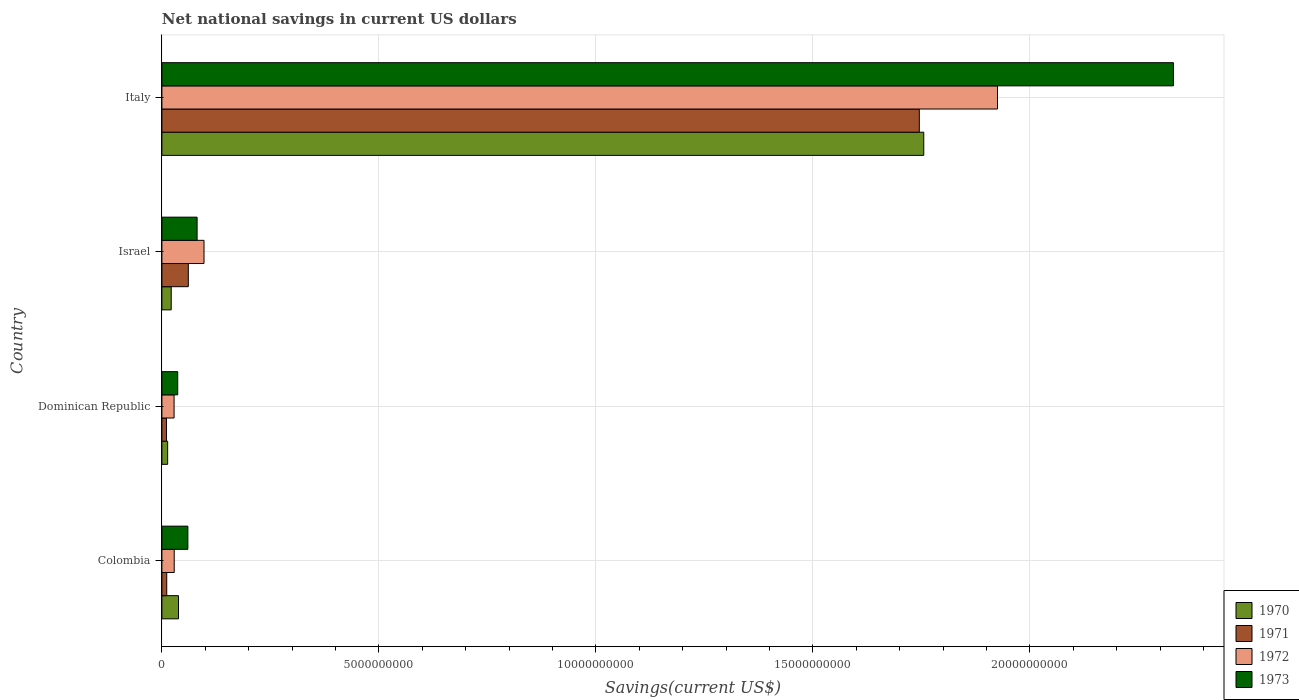Are the number of bars per tick equal to the number of legend labels?
Offer a terse response. Yes. Are the number of bars on each tick of the Y-axis equal?
Give a very brief answer. Yes. How many bars are there on the 4th tick from the top?
Make the answer very short. 4. How many bars are there on the 3rd tick from the bottom?
Provide a succinct answer. 4. What is the label of the 4th group of bars from the top?
Keep it short and to the point. Colombia. In how many cases, is the number of bars for a given country not equal to the number of legend labels?
Ensure brevity in your answer.  0. What is the net national savings in 1973 in Israel?
Offer a terse response. 8.11e+08. Across all countries, what is the maximum net national savings in 1970?
Your answer should be very brief. 1.76e+1. Across all countries, what is the minimum net national savings in 1973?
Make the answer very short. 3.65e+08. In which country was the net national savings in 1972 maximum?
Ensure brevity in your answer.  Italy. In which country was the net national savings in 1971 minimum?
Ensure brevity in your answer.  Dominican Republic. What is the total net national savings in 1972 in the graph?
Your response must be concise. 2.08e+1. What is the difference between the net national savings in 1971 in Dominican Republic and that in Israel?
Provide a succinct answer. -5.03e+08. What is the difference between the net national savings in 1973 in Dominican Republic and the net national savings in 1971 in Italy?
Offer a terse response. -1.71e+1. What is the average net national savings in 1972 per country?
Your response must be concise. 5.20e+09. What is the difference between the net national savings in 1972 and net national savings in 1973 in Colombia?
Provide a short and direct response. -3.14e+08. What is the ratio of the net national savings in 1973 in Dominican Republic to that in Israel?
Your response must be concise. 0.45. Is the difference between the net national savings in 1972 in Israel and Italy greater than the difference between the net national savings in 1973 in Israel and Italy?
Your answer should be very brief. Yes. What is the difference between the highest and the second highest net national savings in 1972?
Offer a very short reply. 1.83e+1. What is the difference between the highest and the lowest net national savings in 1972?
Provide a short and direct response. 1.90e+1. In how many countries, is the net national savings in 1971 greater than the average net national savings in 1971 taken over all countries?
Offer a very short reply. 1. Is the sum of the net national savings in 1972 in Israel and Italy greater than the maximum net national savings in 1971 across all countries?
Ensure brevity in your answer.  Yes. Is it the case that in every country, the sum of the net national savings in 1970 and net national savings in 1971 is greater than the sum of net national savings in 1972 and net national savings in 1973?
Provide a short and direct response. No. What does the 2nd bar from the top in Dominican Republic represents?
Your response must be concise. 1972. Is it the case that in every country, the sum of the net national savings in 1971 and net national savings in 1972 is greater than the net national savings in 1973?
Provide a short and direct response. No. How many bars are there?
Keep it short and to the point. 16. How many countries are there in the graph?
Ensure brevity in your answer.  4. What is the difference between two consecutive major ticks on the X-axis?
Offer a very short reply. 5.00e+09. Does the graph contain any zero values?
Ensure brevity in your answer.  No. How are the legend labels stacked?
Your response must be concise. Vertical. What is the title of the graph?
Give a very brief answer. Net national savings in current US dollars. Does "1961" appear as one of the legend labels in the graph?
Make the answer very short. No. What is the label or title of the X-axis?
Offer a terse response. Savings(current US$). What is the label or title of the Y-axis?
Ensure brevity in your answer.  Country. What is the Savings(current US$) in 1970 in Colombia?
Your answer should be compact. 3.83e+08. What is the Savings(current US$) in 1971 in Colombia?
Keep it short and to the point. 1.11e+08. What is the Savings(current US$) in 1972 in Colombia?
Ensure brevity in your answer.  2.84e+08. What is the Savings(current US$) of 1973 in Colombia?
Your answer should be compact. 5.98e+08. What is the Savings(current US$) in 1970 in Dominican Republic?
Your response must be concise. 1.33e+08. What is the Savings(current US$) in 1971 in Dominican Republic?
Make the answer very short. 1.05e+08. What is the Savings(current US$) of 1972 in Dominican Republic?
Your answer should be very brief. 2.80e+08. What is the Savings(current US$) of 1973 in Dominican Republic?
Provide a succinct answer. 3.65e+08. What is the Savings(current US$) in 1970 in Israel?
Ensure brevity in your answer.  2.15e+08. What is the Savings(current US$) in 1971 in Israel?
Your answer should be compact. 6.09e+08. What is the Savings(current US$) in 1972 in Israel?
Make the answer very short. 9.71e+08. What is the Savings(current US$) of 1973 in Israel?
Offer a terse response. 8.11e+08. What is the Savings(current US$) in 1970 in Italy?
Ensure brevity in your answer.  1.76e+1. What is the Savings(current US$) of 1971 in Italy?
Keep it short and to the point. 1.75e+1. What is the Savings(current US$) of 1972 in Italy?
Offer a very short reply. 1.93e+1. What is the Savings(current US$) of 1973 in Italy?
Offer a terse response. 2.33e+1. Across all countries, what is the maximum Savings(current US$) in 1970?
Provide a succinct answer. 1.76e+1. Across all countries, what is the maximum Savings(current US$) in 1971?
Offer a very short reply. 1.75e+1. Across all countries, what is the maximum Savings(current US$) in 1972?
Provide a short and direct response. 1.93e+1. Across all countries, what is the maximum Savings(current US$) of 1973?
Your answer should be compact. 2.33e+1. Across all countries, what is the minimum Savings(current US$) in 1970?
Keep it short and to the point. 1.33e+08. Across all countries, what is the minimum Savings(current US$) in 1971?
Give a very brief answer. 1.05e+08. Across all countries, what is the minimum Savings(current US$) of 1972?
Your answer should be compact. 2.80e+08. Across all countries, what is the minimum Savings(current US$) in 1973?
Make the answer very short. 3.65e+08. What is the total Savings(current US$) in 1970 in the graph?
Offer a very short reply. 1.83e+1. What is the total Savings(current US$) of 1971 in the graph?
Your response must be concise. 1.83e+1. What is the total Savings(current US$) of 1972 in the graph?
Provide a short and direct response. 2.08e+1. What is the total Savings(current US$) of 1973 in the graph?
Provide a succinct answer. 2.51e+1. What is the difference between the Savings(current US$) of 1970 in Colombia and that in Dominican Republic?
Your answer should be very brief. 2.50e+08. What is the difference between the Savings(current US$) in 1971 in Colombia and that in Dominican Republic?
Provide a succinct answer. 6.03e+06. What is the difference between the Savings(current US$) in 1972 in Colombia and that in Dominican Republic?
Offer a very short reply. 3.48e+06. What is the difference between the Savings(current US$) of 1973 in Colombia and that in Dominican Republic?
Keep it short and to the point. 2.34e+08. What is the difference between the Savings(current US$) of 1970 in Colombia and that in Israel?
Your answer should be very brief. 1.68e+08. What is the difference between the Savings(current US$) in 1971 in Colombia and that in Israel?
Your response must be concise. -4.97e+08. What is the difference between the Savings(current US$) of 1972 in Colombia and that in Israel?
Provide a succinct answer. -6.87e+08. What is the difference between the Savings(current US$) of 1973 in Colombia and that in Israel?
Your answer should be compact. -2.12e+08. What is the difference between the Savings(current US$) in 1970 in Colombia and that in Italy?
Your response must be concise. -1.72e+1. What is the difference between the Savings(current US$) in 1971 in Colombia and that in Italy?
Your answer should be compact. -1.73e+1. What is the difference between the Savings(current US$) in 1972 in Colombia and that in Italy?
Give a very brief answer. -1.90e+1. What is the difference between the Savings(current US$) in 1973 in Colombia and that in Italy?
Make the answer very short. -2.27e+1. What is the difference between the Savings(current US$) of 1970 in Dominican Republic and that in Israel?
Provide a succinct answer. -8.19e+07. What is the difference between the Savings(current US$) in 1971 in Dominican Republic and that in Israel?
Give a very brief answer. -5.03e+08. What is the difference between the Savings(current US$) of 1972 in Dominican Republic and that in Israel?
Your answer should be very brief. -6.90e+08. What is the difference between the Savings(current US$) of 1973 in Dominican Republic and that in Israel?
Your answer should be very brief. -4.46e+08. What is the difference between the Savings(current US$) of 1970 in Dominican Republic and that in Italy?
Offer a very short reply. -1.74e+1. What is the difference between the Savings(current US$) of 1971 in Dominican Republic and that in Italy?
Make the answer very short. -1.73e+1. What is the difference between the Savings(current US$) of 1972 in Dominican Republic and that in Italy?
Your response must be concise. -1.90e+1. What is the difference between the Savings(current US$) in 1973 in Dominican Republic and that in Italy?
Offer a terse response. -2.29e+1. What is the difference between the Savings(current US$) in 1970 in Israel and that in Italy?
Ensure brevity in your answer.  -1.73e+1. What is the difference between the Savings(current US$) in 1971 in Israel and that in Italy?
Your answer should be very brief. -1.68e+1. What is the difference between the Savings(current US$) of 1972 in Israel and that in Italy?
Keep it short and to the point. -1.83e+1. What is the difference between the Savings(current US$) in 1973 in Israel and that in Italy?
Your answer should be compact. -2.25e+1. What is the difference between the Savings(current US$) of 1970 in Colombia and the Savings(current US$) of 1971 in Dominican Republic?
Your response must be concise. 2.77e+08. What is the difference between the Savings(current US$) of 1970 in Colombia and the Savings(current US$) of 1972 in Dominican Republic?
Give a very brief answer. 1.02e+08. What is the difference between the Savings(current US$) of 1970 in Colombia and the Savings(current US$) of 1973 in Dominican Republic?
Provide a short and direct response. 1.82e+07. What is the difference between the Savings(current US$) of 1971 in Colombia and the Savings(current US$) of 1972 in Dominican Republic?
Provide a short and direct response. -1.69e+08. What is the difference between the Savings(current US$) in 1971 in Colombia and the Savings(current US$) in 1973 in Dominican Republic?
Provide a succinct answer. -2.53e+08. What is the difference between the Savings(current US$) in 1972 in Colombia and the Savings(current US$) in 1973 in Dominican Republic?
Give a very brief answer. -8.05e+07. What is the difference between the Savings(current US$) of 1970 in Colombia and the Savings(current US$) of 1971 in Israel?
Offer a terse response. -2.26e+08. What is the difference between the Savings(current US$) of 1970 in Colombia and the Savings(current US$) of 1972 in Israel?
Provide a succinct answer. -5.88e+08. What is the difference between the Savings(current US$) of 1970 in Colombia and the Savings(current US$) of 1973 in Israel?
Make the answer very short. -4.28e+08. What is the difference between the Savings(current US$) of 1971 in Colombia and the Savings(current US$) of 1972 in Israel?
Your response must be concise. -8.59e+08. What is the difference between the Savings(current US$) of 1971 in Colombia and the Savings(current US$) of 1973 in Israel?
Provide a short and direct response. -6.99e+08. What is the difference between the Savings(current US$) in 1972 in Colombia and the Savings(current US$) in 1973 in Israel?
Give a very brief answer. -5.27e+08. What is the difference between the Savings(current US$) in 1970 in Colombia and the Savings(current US$) in 1971 in Italy?
Give a very brief answer. -1.71e+1. What is the difference between the Savings(current US$) in 1970 in Colombia and the Savings(current US$) in 1972 in Italy?
Ensure brevity in your answer.  -1.89e+1. What is the difference between the Savings(current US$) of 1970 in Colombia and the Savings(current US$) of 1973 in Italy?
Ensure brevity in your answer.  -2.29e+1. What is the difference between the Savings(current US$) of 1971 in Colombia and the Savings(current US$) of 1972 in Italy?
Provide a succinct answer. -1.91e+1. What is the difference between the Savings(current US$) of 1971 in Colombia and the Savings(current US$) of 1973 in Italy?
Your answer should be compact. -2.32e+1. What is the difference between the Savings(current US$) in 1972 in Colombia and the Savings(current US$) in 1973 in Italy?
Give a very brief answer. -2.30e+1. What is the difference between the Savings(current US$) in 1970 in Dominican Republic and the Savings(current US$) in 1971 in Israel?
Give a very brief answer. -4.76e+08. What is the difference between the Savings(current US$) of 1970 in Dominican Republic and the Savings(current US$) of 1972 in Israel?
Ensure brevity in your answer.  -8.38e+08. What is the difference between the Savings(current US$) in 1970 in Dominican Republic and the Savings(current US$) in 1973 in Israel?
Keep it short and to the point. -6.78e+08. What is the difference between the Savings(current US$) of 1971 in Dominican Republic and the Savings(current US$) of 1972 in Israel?
Give a very brief answer. -8.65e+08. What is the difference between the Savings(current US$) in 1971 in Dominican Republic and the Savings(current US$) in 1973 in Israel?
Ensure brevity in your answer.  -7.05e+08. What is the difference between the Savings(current US$) in 1972 in Dominican Republic and the Savings(current US$) in 1973 in Israel?
Ensure brevity in your answer.  -5.30e+08. What is the difference between the Savings(current US$) of 1970 in Dominican Republic and the Savings(current US$) of 1971 in Italy?
Offer a very short reply. -1.73e+1. What is the difference between the Savings(current US$) in 1970 in Dominican Republic and the Savings(current US$) in 1972 in Italy?
Your response must be concise. -1.91e+1. What is the difference between the Savings(current US$) in 1970 in Dominican Republic and the Savings(current US$) in 1973 in Italy?
Offer a terse response. -2.32e+1. What is the difference between the Savings(current US$) in 1971 in Dominican Republic and the Savings(current US$) in 1972 in Italy?
Keep it short and to the point. -1.91e+1. What is the difference between the Savings(current US$) of 1971 in Dominican Republic and the Savings(current US$) of 1973 in Italy?
Keep it short and to the point. -2.32e+1. What is the difference between the Savings(current US$) in 1972 in Dominican Republic and the Savings(current US$) in 1973 in Italy?
Keep it short and to the point. -2.30e+1. What is the difference between the Savings(current US$) in 1970 in Israel and the Savings(current US$) in 1971 in Italy?
Provide a succinct answer. -1.72e+1. What is the difference between the Savings(current US$) of 1970 in Israel and the Savings(current US$) of 1972 in Italy?
Offer a terse response. -1.90e+1. What is the difference between the Savings(current US$) of 1970 in Israel and the Savings(current US$) of 1973 in Italy?
Your response must be concise. -2.31e+1. What is the difference between the Savings(current US$) of 1971 in Israel and the Savings(current US$) of 1972 in Italy?
Your answer should be very brief. -1.86e+1. What is the difference between the Savings(current US$) in 1971 in Israel and the Savings(current US$) in 1973 in Italy?
Give a very brief answer. -2.27e+1. What is the difference between the Savings(current US$) in 1972 in Israel and the Savings(current US$) in 1973 in Italy?
Your response must be concise. -2.23e+1. What is the average Savings(current US$) of 1970 per country?
Your answer should be very brief. 4.57e+09. What is the average Savings(current US$) in 1971 per country?
Make the answer very short. 4.57e+09. What is the average Savings(current US$) of 1972 per country?
Ensure brevity in your answer.  5.20e+09. What is the average Savings(current US$) in 1973 per country?
Your answer should be compact. 6.27e+09. What is the difference between the Savings(current US$) of 1970 and Savings(current US$) of 1971 in Colombia?
Offer a very short reply. 2.71e+08. What is the difference between the Savings(current US$) in 1970 and Savings(current US$) in 1972 in Colombia?
Keep it short and to the point. 9.87e+07. What is the difference between the Savings(current US$) of 1970 and Savings(current US$) of 1973 in Colombia?
Ensure brevity in your answer.  -2.16e+08. What is the difference between the Savings(current US$) of 1971 and Savings(current US$) of 1972 in Colombia?
Your response must be concise. -1.73e+08. What is the difference between the Savings(current US$) of 1971 and Savings(current US$) of 1973 in Colombia?
Provide a short and direct response. -4.87e+08. What is the difference between the Savings(current US$) in 1972 and Savings(current US$) in 1973 in Colombia?
Ensure brevity in your answer.  -3.14e+08. What is the difference between the Savings(current US$) of 1970 and Savings(current US$) of 1971 in Dominican Republic?
Offer a very short reply. 2.74e+07. What is the difference between the Savings(current US$) in 1970 and Savings(current US$) in 1972 in Dominican Republic?
Ensure brevity in your answer.  -1.48e+08. What is the difference between the Savings(current US$) of 1970 and Savings(current US$) of 1973 in Dominican Republic?
Offer a very short reply. -2.32e+08. What is the difference between the Savings(current US$) in 1971 and Savings(current US$) in 1972 in Dominican Republic?
Offer a terse response. -1.75e+08. What is the difference between the Savings(current US$) of 1971 and Savings(current US$) of 1973 in Dominican Republic?
Offer a terse response. -2.59e+08. What is the difference between the Savings(current US$) of 1972 and Savings(current US$) of 1973 in Dominican Republic?
Make the answer very short. -8.40e+07. What is the difference between the Savings(current US$) of 1970 and Savings(current US$) of 1971 in Israel?
Your answer should be very brief. -3.94e+08. What is the difference between the Savings(current US$) in 1970 and Savings(current US$) in 1972 in Israel?
Provide a succinct answer. -7.56e+08. What is the difference between the Savings(current US$) in 1970 and Savings(current US$) in 1973 in Israel?
Provide a succinct answer. -5.96e+08. What is the difference between the Savings(current US$) of 1971 and Savings(current US$) of 1972 in Israel?
Ensure brevity in your answer.  -3.62e+08. What is the difference between the Savings(current US$) of 1971 and Savings(current US$) of 1973 in Israel?
Offer a terse response. -2.02e+08. What is the difference between the Savings(current US$) of 1972 and Savings(current US$) of 1973 in Israel?
Offer a very short reply. 1.60e+08. What is the difference between the Savings(current US$) of 1970 and Savings(current US$) of 1971 in Italy?
Your answer should be very brief. 1.03e+08. What is the difference between the Savings(current US$) of 1970 and Savings(current US$) of 1972 in Italy?
Offer a very short reply. -1.70e+09. What is the difference between the Savings(current US$) of 1970 and Savings(current US$) of 1973 in Italy?
Provide a short and direct response. -5.75e+09. What is the difference between the Savings(current US$) in 1971 and Savings(current US$) in 1972 in Italy?
Ensure brevity in your answer.  -1.80e+09. What is the difference between the Savings(current US$) of 1971 and Savings(current US$) of 1973 in Italy?
Make the answer very short. -5.86e+09. What is the difference between the Savings(current US$) of 1972 and Savings(current US$) of 1973 in Italy?
Your answer should be compact. -4.05e+09. What is the ratio of the Savings(current US$) in 1970 in Colombia to that in Dominican Republic?
Your answer should be compact. 2.88. What is the ratio of the Savings(current US$) of 1971 in Colombia to that in Dominican Republic?
Your response must be concise. 1.06. What is the ratio of the Savings(current US$) in 1972 in Colombia to that in Dominican Republic?
Your answer should be very brief. 1.01. What is the ratio of the Savings(current US$) in 1973 in Colombia to that in Dominican Republic?
Keep it short and to the point. 1.64. What is the ratio of the Savings(current US$) of 1970 in Colombia to that in Israel?
Your answer should be compact. 1.78. What is the ratio of the Savings(current US$) in 1971 in Colombia to that in Israel?
Provide a short and direct response. 0.18. What is the ratio of the Savings(current US$) in 1972 in Colombia to that in Israel?
Make the answer very short. 0.29. What is the ratio of the Savings(current US$) in 1973 in Colombia to that in Israel?
Offer a terse response. 0.74. What is the ratio of the Savings(current US$) of 1970 in Colombia to that in Italy?
Offer a very short reply. 0.02. What is the ratio of the Savings(current US$) in 1971 in Colombia to that in Italy?
Make the answer very short. 0.01. What is the ratio of the Savings(current US$) in 1972 in Colombia to that in Italy?
Provide a succinct answer. 0.01. What is the ratio of the Savings(current US$) in 1973 in Colombia to that in Italy?
Offer a terse response. 0.03. What is the ratio of the Savings(current US$) in 1970 in Dominican Republic to that in Israel?
Provide a succinct answer. 0.62. What is the ratio of the Savings(current US$) in 1971 in Dominican Republic to that in Israel?
Provide a short and direct response. 0.17. What is the ratio of the Savings(current US$) in 1972 in Dominican Republic to that in Israel?
Your answer should be very brief. 0.29. What is the ratio of the Savings(current US$) in 1973 in Dominican Republic to that in Israel?
Your response must be concise. 0.45. What is the ratio of the Savings(current US$) of 1970 in Dominican Republic to that in Italy?
Your answer should be compact. 0.01. What is the ratio of the Savings(current US$) in 1971 in Dominican Republic to that in Italy?
Give a very brief answer. 0.01. What is the ratio of the Savings(current US$) in 1972 in Dominican Republic to that in Italy?
Provide a short and direct response. 0.01. What is the ratio of the Savings(current US$) in 1973 in Dominican Republic to that in Italy?
Offer a terse response. 0.02. What is the ratio of the Savings(current US$) in 1970 in Israel to that in Italy?
Ensure brevity in your answer.  0.01. What is the ratio of the Savings(current US$) in 1971 in Israel to that in Italy?
Your answer should be compact. 0.03. What is the ratio of the Savings(current US$) of 1972 in Israel to that in Italy?
Offer a very short reply. 0.05. What is the ratio of the Savings(current US$) in 1973 in Israel to that in Italy?
Give a very brief answer. 0.03. What is the difference between the highest and the second highest Savings(current US$) in 1970?
Provide a short and direct response. 1.72e+1. What is the difference between the highest and the second highest Savings(current US$) in 1971?
Offer a terse response. 1.68e+1. What is the difference between the highest and the second highest Savings(current US$) in 1972?
Your answer should be compact. 1.83e+1. What is the difference between the highest and the second highest Savings(current US$) in 1973?
Your response must be concise. 2.25e+1. What is the difference between the highest and the lowest Savings(current US$) of 1970?
Provide a short and direct response. 1.74e+1. What is the difference between the highest and the lowest Savings(current US$) of 1971?
Ensure brevity in your answer.  1.73e+1. What is the difference between the highest and the lowest Savings(current US$) of 1972?
Give a very brief answer. 1.90e+1. What is the difference between the highest and the lowest Savings(current US$) in 1973?
Your answer should be very brief. 2.29e+1. 